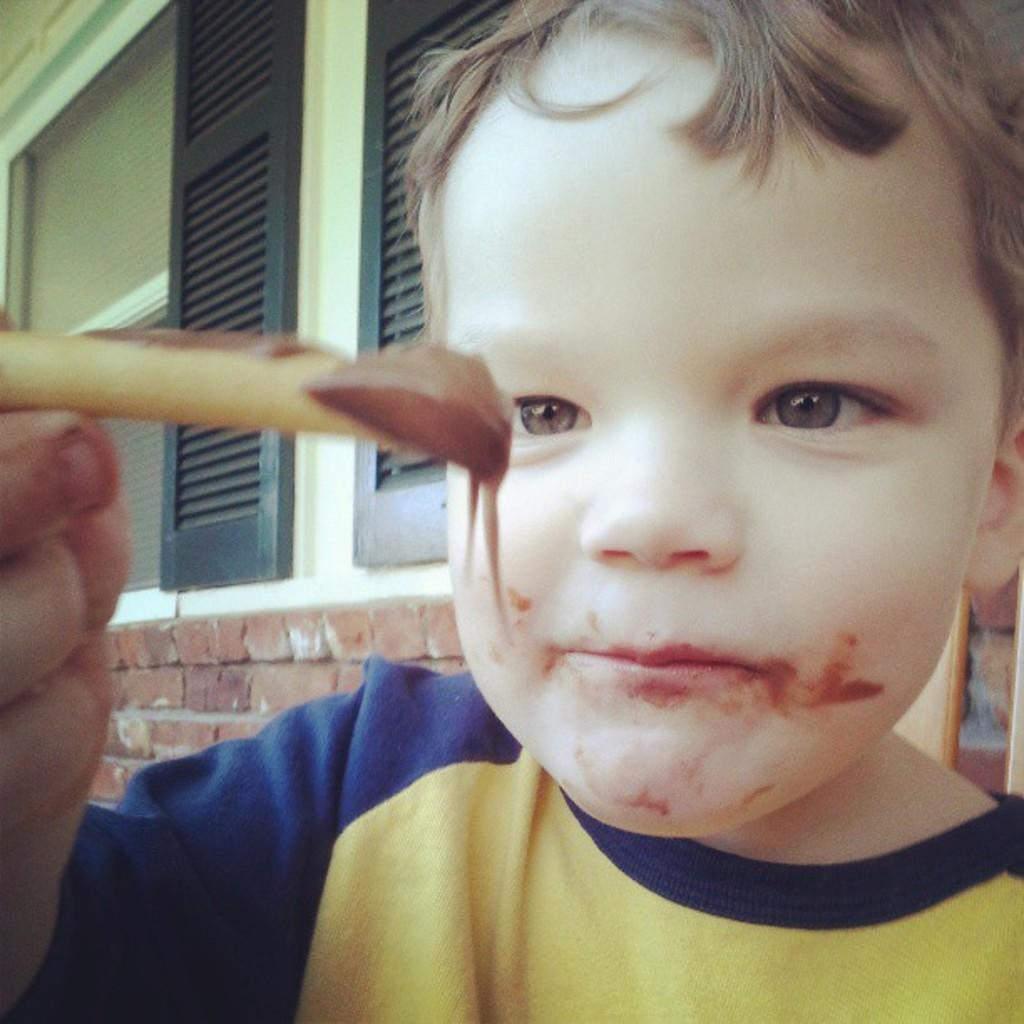What is the main subject of the image? The main subject of the image is a kid standing. What is the kid holding in the image? The kid is holding a food item. What can be seen in the background of the image? There are windows and a brick wall visible in the background of the image. What type of hearing aid is the kid wearing in the image? There is no hearing aid visible in the image; the kid is simply standing and holding a food item. 